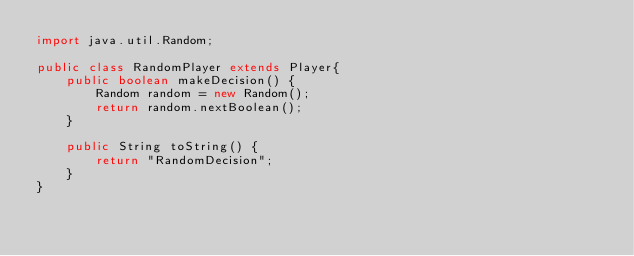<code> <loc_0><loc_0><loc_500><loc_500><_Java_>import java.util.Random;

public class RandomPlayer extends Player{
    public boolean makeDecision() {
        Random random = new Random();
        return random.nextBoolean();
    }

    public String toString() {
        return "RandomDecision";
    }
}
</code> 